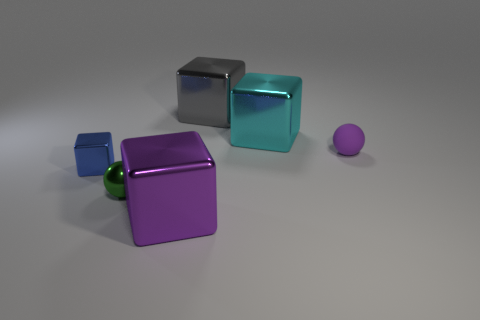What number of large metal blocks are the same color as the rubber sphere?
Give a very brief answer. 1. There is a purple metallic object that is the same size as the cyan cube; what shape is it?
Provide a short and direct response. Cube. There is a metallic block that is both to the right of the blue metallic cube and in front of the big cyan cube; how big is it?
Keep it short and to the point. Large. What is the material of the blue object that is the same shape as the large purple object?
Provide a short and direct response. Metal. There is a small thing to the right of the big cube in front of the big cyan thing; what is its material?
Keep it short and to the point. Rubber. Do the big cyan object and the purple thing that is to the left of the big gray object have the same shape?
Offer a very short reply. Yes. What number of rubber objects are either large gray cubes or large brown spheres?
Keep it short and to the point. 0. The tiny thing that is to the right of the large metal block in front of the rubber sphere that is right of the big cyan object is what color?
Make the answer very short. Purple. What number of other things are made of the same material as the cyan block?
Give a very brief answer. 4. Does the big metal object behind the large cyan metallic object have the same shape as the blue metal object?
Make the answer very short. Yes. 